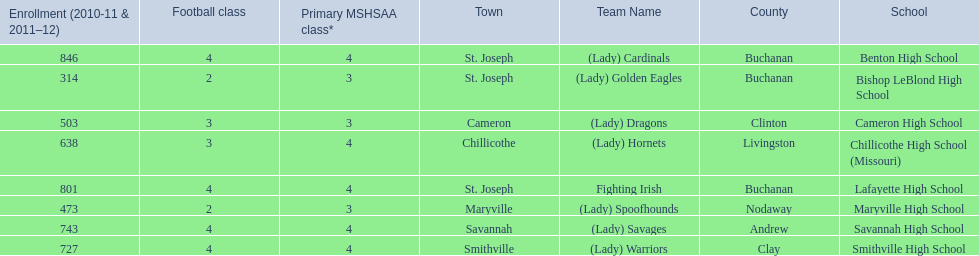What school in midland empire conference has 846 students enrolled? Benton High School. What school has 314 students enrolled? Bishop LeBlond High School. What school had 638 students enrolled? Chillicothe High School (Missouri). 